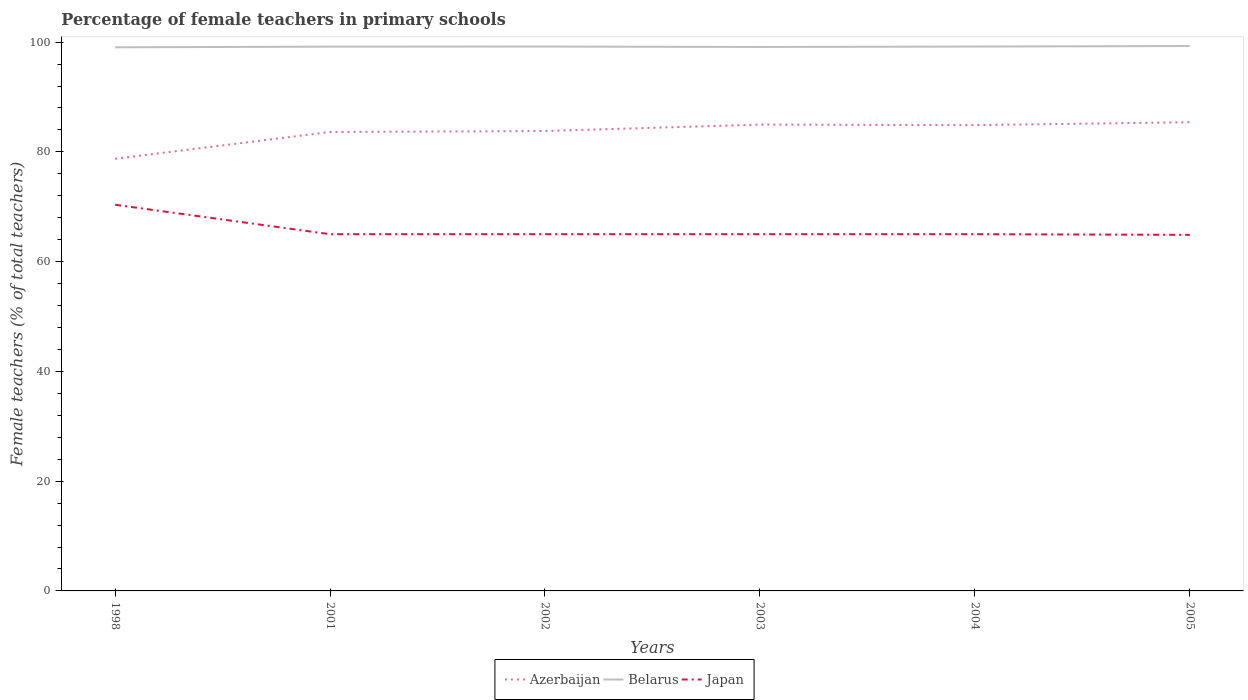How many different coloured lines are there?
Ensure brevity in your answer.  3. Is the number of lines equal to the number of legend labels?
Offer a terse response. Yes. Across all years, what is the maximum percentage of female teachers in Belarus?
Provide a succinct answer. 99.06. In which year was the percentage of female teachers in Azerbaijan maximum?
Your answer should be very brief. 1998. What is the total percentage of female teachers in Azerbaijan in the graph?
Your answer should be compact. -4.88. What is the difference between the highest and the second highest percentage of female teachers in Belarus?
Your response must be concise. 0.23. Is the percentage of female teachers in Azerbaijan strictly greater than the percentage of female teachers in Belarus over the years?
Your response must be concise. Yes. How many lines are there?
Your response must be concise. 3. What is the difference between two consecutive major ticks on the Y-axis?
Offer a very short reply. 20. Are the values on the major ticks of Y-axis written in scientific E-notation?
Provide a short and direct response. No. How many legend labels are there?
Make the answer very short. 3. What is the title of the graph?
Provide a short and direct response. Percentage of female teachers in primary schools. What is the label or title of the Y-axis?
Provide a succinct answer. Female teachers (% of total teachers). What is the Female teachers (% of total teachers) of Azerbaijan in 1998?
Ensure brevity in your answer.  78.75. What is the Female teachers (% of total teachers) of Belarus in 1998?
Provide a short and direct response. 99.06. What is the Female teachers (% of total teachers) in Japan in 1998?
Give a very brief answer. 70.37. What is the Female teachers (% of total teachers) of Azerbaijan in 2001?
Provide a short and direct response. 83.63. What is the Female teachers (% of total teachers) of Belarus in 2001?
Provide a succinct answer. 99.18. What is the Female teachers (% of total teachers) of Japan in 2001?
Give a very brief answer. 65. What is the Female teachers (% of total teachers) of Azerbaijan in 2002?
Keep it short and to the point. 83.81. What is the Female teachers (% of total teachers) in Belarus in 2002?
Your answer should be very brief. 99.2. What is the Female teachers (% of total teachers) of Japan in 2002?
Provide a short and direct response. 65. What is the Female teachers (% of total teachers) of Azerbaijan in 2003?
Offer a very short reply. 84.97. What is the Female teachers (% of total teachers) of Belarus in 2003?
Offer a very short reply. 99.12. What is the Female teachers (% of total teachers) of Japan in 2003?
Your response must be concise. 65. What is the Female teachers (% of total teachers) of Azerbaijan in 2004?
Offer a terse response. 84.88. What is the Female teachers (% of total teachers) in Belarus in 2004?
Offer a terse response. 99.2. What is the Female teachers (% of total teachers) of Japan in 2004?
Provide a succinct answer. 65. What is the Female teachers (% of total teachers) of Azerbaijan in 2005?
Offer a terse response. 85.41. What is the Female teachers (% of total teachers) of Belarus in 2005?
Provide a short and direct response. 99.29. What is the Female teachers (% of total teachers) of Japan in 2005?
Your answer should be very brief. 64.88. Across all years, what is the maximum Female teachers (% of total teachers) in Azerbaijan?
Provide a short and direct response. 85.41. Across all years, what is the maximum Female teachers (% of total teachers) of Belarus?
Provide a short and direct response. 99.29. Across all years, what is the maximum Female teachers (% of total teachers) of Japan?
Provide a short and direct response. 70.37. Across all years, what is the minimum Female teachers (% of total teachers) in Azerbaijan?
Provide a short and direct response. 78.75. Across all years, what is the minimum Female teachers (% of total teachers) in Belarus?
Your answer should be compact. 99.06. Across all years, what is the minimum Female teachers (% of total teachers) in Japan?
Keep it short and to the point. 64.88. What is the total Female teachers (% of total teachers) of Azerbaijan in the graph?
Provide a short and direct response. 501.44. What is the total Female teachers (% of total teachers) of Belarus in the graph?
Offer a terse response. 595.05. What is the total Female teachers (% of total teachers) of Japan in the graph?
Your answer should be very brief. 395.27. What is the difference between the Female teachers (% of total teachers) in Azerbaijan in 1998 and that in 2001?
Provide a short and direct response. -4.88. What is the difference between the Female teachers (% of total teachers) of Belarus in 1998 and that in 2001?
Make the answer very short. -0.12. What is the difference between the Female teachers (% of total teachers) of Japan in 1998 and that in 2001?
Provide a short and direct response. 5.37. What is the difference between the Female teachers (% of total teachers) of Azerbaijan in 1998 and that in 2002?
Your answer should be very brief. -5.06. What is the difference between the Female teachers (% of total teachers) of Belarus in 1998 and that in 2002?
Provide a succinct answer. -0.14. What is the difference between the Female teachers (% of total teachers) of Japan in 1998 and that in 2002?
Offer a very short reply. 5.37. What is the difference between the Female teachers (% of total teachers) of Azerbaijan in 1998 and that in 2003?
Make the answer very short. -6.23. What is the difference between the Female teachers (% of total teachers) of Belarus in 1998 and that in 2003?
Keep it short and to the point. -0.06. What is the difference between the Female teachers (% of total teachers) in Japan in 1998 and that in 2003?
Make the answer very short. 5.37. What is the difference between the Female teachers (% of total teachers) of Azerbaijan in 1998 and that in 2004?
Keep it short and to the point. -6.13. What is the difference between the Female teachers (% of total teachers) of Belarus in 1998 and that in 2004?
Provide a succinct answer. -0.14. What is the difference between the Female teachers (% of total teachers) of Japan in 1998 and that in 2004?
Provide a succinct answer. 5.37. What is the difference between the Female teachers (% of total teachers) of Azerbaijan in 1998 and that in 2005?
Your response must be concise. -6.66. What is the difference between the Female teachers (% of total teachers) of Belarus in 1998 and that in 2005?
Make the answer very short. -0.23. What is the difference between the Female teachers (% of total teachers) in Japan in 1998 and that in 2005?
Make the answer very short. 5.48. What is the difference between the Female teachers (% of total teachers) in Azerbaijan in 2001 and that in 2002?
Give a very brief answer. -0.18. What is the difference between the Female teachers (% of total teachers) in Belarus in 2001 and that in 2002?
Provide a short and direct response. -0.02. What is the difference between the Female teachers (% of total teachers) of Japan in 2001 and that in 2002?
Offer a terse response. -0. What is the difference between the Female teachers (% of total teachers) in Azerbaijan in 2001 and that in 2003?
Provide a succinct answer. -1.34. What is the difference between the Female teachers (% of total teachers) in Belarus in 2001 and that in 2003?
Provide a succinct answer. 0.06. What is the difference between the Female teachers (% of total teachers) in Japan in 2001 and that in 2003?
Provide a succinct answer. -0. What is the difference between the Female teachers (% of total teachers) of Azerbaijan in 2001 and that in 2004?
Give a very brief answer. -1.25. What is the difference between the Female teachers (% of total teachers) in Belarus in 2001 and that in 2004?
Provide a succinct answer. -0.01. What is the difference between the Female teachers (% of total teachers) of Japan in 2001 and that in 2004?
Your answer should be very brief. -0. What is the difference between the Female teachers (% of total teachers) of Azerbaijan in 2001 and that in 2005?
Your response must be concise. -1.78. What is the difference between the Female teachers (% of total teachers) in Belarus in 2001 and that in 2005?
Offer a very short reply. -0.11. What is the difference between the Female teachers (% of total teachers) of Japan in 2001 and that in 2005?
Offer a terse response. 0.12. What is the difference between the Female teachers (% of total teachers) of Azerbaijan in 2002 and that in 2003?
Keep it short and to the point. -1.17. What is the difference between the Female teachers (% of total teachers) of Belarus in 2002 and that in 2003?
Keep it short and to the point. 0.08. What is the difference between the Female teachers (% of total teachers) in Japan in 2002 and that in 2003?
Give a very brief answer. -0. What is the difference between the Female teachers (% of total teachers) of Azerbaijan in 2002 and that in 2004?
Your response must be concise. -1.07. What is the difference between the Female teachers (% of total teachers) of Belarus in 2002 and that in 2004?
Offer a terse response. 0. What is the difference between the Female teachers (% of total teachers) of Japan in 2002 and that in 2004?
Provide a short and direct response. -0. What is the difference between the Female teachers (% of total teachers) of Azerbaijan in 2002 and that in 2005?
Offer a very short reply. -1.6. What is the difference between the Female teachers (% of total teachers) of Belarus in 2002 and that in 2005?
Your answer should be compact. -0.1. What is the difference between the Female teachers (% of total teachers) of Japan in 2002 and that in 2005?
Your answer should be very brief. 0.12. What is the difference between the Female teachers (% of total teachers) of Azerbaijan in 2003 and that in 2004?
Keep it short and to the point. 0.1. What is the difference between the Female teachers (% of total teachers) of Belarus in 2003 and that in 2004?
Keep it short and to the point. -0.08. What is the difference between the Female teachers (% of total teachers) in Japan in 2003 and that in 2004?
Your answer should be very brief. 0. What is the difference between the Female teachers (% of total teachers) of Azerbaijan in 2003 and that in 2005?
Offer a very short reply. -0.44. What is the difference between the Female teachers (% of total teachers) of Belarus in 2003 and that in 2005?
Your answer should be very brief. -0.17. What is the difference between the Female teachers (% of total teachers) of Japan in 2003 and that in 2005?
Your answer should be very brief. 0.12. What is the difference between the Female teachers (% of total teachers) of Azerbaijan in 2004 and that in 2005?
Provide a short and direct response. -0.53. What is the difference between the Female teachers (% of total teachers) of Belarus in 2004 and that in 2005?
Offer a terse response. -0.1. What is the difference between the Female teachers (% of total teachers) in Japan in 2004 and that in 2005?
Ensure brevity in your answer.  0.12. What is the difference between the Female teachers (% of total teachers) in Azerbaijan in 1998 and the Female teachers (% of total teachers) in Belarus in 2001?
Your response must be concise. -20.44. What is the difference between the Female teachers (% of total teachers) in Azerbaijan in 1998 and the Female teachers (% of total teachers) in Japan in 2001?
Provide a succinct answer. 13.74. What is the difference between the Female teachers (% of total teachers) of Belarus in 1998 and the Female teachers (% of total teachers) of Japan in 2001?
Your answer should be compact. 34.06. What is the difference between the Female teachers (% of total teachers) in Azerbaijan in 1998 and the Female teachers (% of total teachers) in Belarus in 2002?
Give a very brief answer. -20.45. What is the difference between the Female teachers (% of total teachers) in Azerbaijan in 1998 and the Female teachers (% of total teachers) in Japan in 2002?
Give a very brief answer. 13.74. What is the difference between the Female teachers (% of total teachers) in Belarus in 1998 and the Female teachers (% of total teachers) in Japan in 2002?
Provide a succinct answer. 34.06. What is the difference between the Female teachers (% of total teachers) of Azerbaijan in 1998 and the Female teachers (% of total teachers) of Belarus in 2003?
Your answer should be very brief. -20.37. What is the difference between the Female teachers (% of total teachers) of Azerbaijan in 1998 and the Female teachers (% of total teachers) of Japan in 2003?
Your answer should be compact. 13.74. What is the difference between the Female teachers (% of total teachers) of Belarus in 1998 and the Female teachers (% of total teachers) of Japan in 2003?
Your response must be concise. 34.06. What is the difference between the Female teachers (% of total teachers) of Azerbaijan in 1998 and the Female teachers (% of total teachers) of Belarus in 2004?
Your answer should be very brief. -20.45. What is the difference between the Female teachers (% of total teachers) in Azerbaijan in 1998 and the Female teachers (% of total teachers) in Japan in 2004?
Your answer should be very brief. 13.74. What is the difference between the Female teachers (% of total teachers) of Belarus in 1998 and the Female teachers (% of total teachers) of Japan in 2004?
Keep it short and to the point. 34.06. What is the difference between the Female teachers (% of total teachers) of Azerbaijan in 1998 and the Female teachers (% of total teachers) of Belarus in 2005?
Make the answer very short. -20.55. What is the difference between the Female teachers (% of total teachers) of Azerbaijan in 1998 and the Female teachers (% of total teachers) of Japan in 2005?
Keep it short and to the point. 13.86. What is the difference between the Female teachers (% of total teachers) of Belarus in 1998 and the Female teachers (% of total teachers) of Japan in 2005?
Your response must be concise. 34.17. What is the difference between the Female teachers (% of total teachers) of Azerbaijan in 2001 and the Female teachers (% of total teachers) of Belarus in 2002?
Keep it short and to the point. -15.57. What is the difference between the Female teachers (% of total teachers) in Azerbaijan in 2001 and the Female teachers (% of total teachers) in Japan in 2002?
Keep it short and to the point. 18.63. What is the difference between the Female teachers (% of total teachers) of Belarus in 2001 and the Female teachers (% of total teachers) of Japan in 2002?
Ensure brevity in your answer.  34.18. What is the difference between the Female teachers (% of total teachers) in Azerbaijan in 2001 and the Female teachers (% of total teachers) in Belarus in 2003?
Your answer should be very brief. -15.49. What is the difference between the Female teachers (% of total teachers) in Azerbaijan in 2001 and the Female teachers (% of total teachers) in Japan in 2003?
Provide a short and direct response. 18.63. What is the difference between the Female teachers (% of total teachers) of Belarus in 2001 and the Female teachers (% of total teachers) of Japan in 2003?
Keep it short and to the point. 34.18. What is the difference between the Female teachers (% of total teachers) in Azerbaijan in 2001 and the Female teachers (% of total teachers) in Belarus in 2004?
Your answer should be very brief. -15.57. What is the difference between the Female teachers (% of total teachers) of Azerbaijan in 2001 and the Female teachers (% of total teachers) of Japan in 2004?
Ensure brevity in your answer.  18.63. What is the difference between the Female teachers (% of total teachers) of Belarus in 2001 and the Female teachers (% of total teachers) of Japan in 2004?
Your response must be concise. 34.18. What is the difference between the Female teachers (% of total teachers) of Azerbaijan in 2001 and the Female teachers (% of total teachers) of Belarus in 2005?
Ensure brevity in your answer.  -15.67. What is the difference between the Female teachers (% of total teachers) in Azerbaijan in 2001 and the Female teachers (% of total teachers) in Japan in 2005?
Keep it short and to the point. 18.74. What is the difference between the Female teachers (% of total teachers) in Belarus in 2001 and the Female teachers (% of total teachers) in Japan in 2005?
Make the answer very short. 34.3. What is the difference between the Female teachers (% of total teachers) in Azerbaijan in 2002 and the Female teachers (% of total teachers) in Belarus in 2003?
Ensure brevity in your answer.  -15.31. What is the difference between the Female teachers (% of total teachers) of Azerbaijan in 2002 and the Female teachers (% of total teachers) of Japan in 2003?
Keep it short and to the point. 18.8. What is the difference between the Female teachers (% of total teachers) in Belarus in 2002 and the Female teachers (% of total teachers) in Japan in 2003?
Your answer should be compact. 34.2. What is the difference between the Female teachers (% of total teachers) of Azerbaijan in 2002 and the Female teachers (% of total teachers) of Belarus in 2004?
Offer a terse response. -15.39. What is the difference between the Female teachers (% of total teachers) of Azerbaijan in 2002 and the Female teachers (% of total teachers) of Japan in 2004?
Offer a terse response. 18.8. What is the difference between the Female teachers (% of total teachers) of Belarus in 2002 and the Female teachers (% of total teachers) of Japan in 2004?
Your response must be concise. 34.2. What is the difference between the Female teachers (% of total teachers) of Azerbaijan in 2002 and the Female teachers (% of total teachers) of Belarus in 2005?
Make the answer very short. -15.49. What is the difference between the Female teachers (% of total teachers) in Azerbaijan in 2002 and the Female teachers (% of total teachers) in Japan in 2005?
Provide a short and direct response. 18.92. What is the difference between the Female teachers (% of total teachers) of Belarus in 2002 and the Female teachers (% of total teachers) of Japan in 2005?
Provide a succinct answer. 34.31. What is the difference between the Female teachers (% of total teachers) in Azerbaijan in 2003 and the Female teachers (% of total teachers) in Belarus in 2004?
Your response must be concise. -14.22. What is the difference between the Female teachers (% of total teachers) of Azerbaijan in 2003 and the Female teachers (% of total teachers) of Japan in 2004?
Your response must be concise. 19.97. What is the difference between the Female teachers (% of total teachers) in Belarus in 2003 and the Female teachers (% of total teachers) in Japan in 2004?
Make the answer very short. 34.12. What is the difference between the Female teachers (% of total teachers) in Azerbaijan in 2003 and the Female teachers (% of total teachers) in Belarus in 2005?
Offer a very short reply. -14.32. What is the difference between the Female teachers (% of total teachers) of Azerbaijan in 2003 and the Female teachers (% of total teachers) of Japan in 2005?
Provide a short and direct response. 20.09. What is the difference between the Female teachers (% of total teachers) of Belarus in 2003 and the Female teachers (% of total teachers) of Japan in 2005?
Your answer should be very brief. 34.24. What is the difference between the Female teachers (% of total teachers) of Azerbaijan in 2004 and the Female teachers (% of total teachers) of Belarus in 2005?
Your response must be concise. -14.42. What is the difference between the Female teachers (% of total teachers) in Azerbaijan in 2004 and the Female teachers (% of total teachers) in Japan in 2005?
Offer a terse response. 19.99. What is the difference between the Female teachers (% of total teachers) in Belarus in 2004 and the Female teachers (% of total teachers) in Japan in 2005?
Provide a short and direct response. 34.31. What is the average Female teachers (% of total teachers) in Azerbaijan per year?
Give a very brief answer. 83.57. What is the average Female teachers (% of total teachers) in Belarus per year?
Make the answer very short. 99.18. What is the average Female teachers (% of total teachers) in Japan per year?
Offer a very short reply. 65.88. In the year 1998, what is the difference between the Female teachers (% of total teachers) of Azerbaijan and Female teachers (% of total teachers) of Belarus?
Offer a terse response. -20.31. In the year 1998, what is the difference between the Female teachers (% of total teachers) of Azerbaijan and Female teachers (% of total teachers) of Japan?
Your response must be concise. 8.38. In the year 1998, what is the difference between the Female teachers (% of total teachers) of Belarus and Female teachers (% of total teachers) of Japan?
Your response must be concise. 28.69. In the year 2001, what is the difference between the Female teachers (% of total teachers) of Azerbaijan and Female teachers (% of total teachers) of Belarus?
Ensure brevity in your answer.  -15.55. In the year 2001, what is the difference between the Female teachers (% of total teachers) in Azerbaijan and Female teachers (% of total teachers) in Japan?
Provide a succinct answer. 18.63. In the year 2001, what is the difference between the Female teachers (% of total teachers) in Belarus and Female teachers (% of total teachers) in Japan?
Your answer should be very brief. 34.18. In the year 2002, what is the difference between the Female teachers (% of total teachers) in Azerbaijan and Female teachers (% of total teachers) in Belarus?
Your answer should be compact. -15.39. In the year 2002, what is the difference between the Female teachers (% of total teachers) of Azerbaijan and Female teachers (% of total teachers) of Japan?
Your answer should be compact. 18.8. In the year 2002, what is the difference between the Female teachers (% of total teachers) of Belarus and Female teachers (% of total teachers) of Japan?
Offer a very short reply. 34.2. In the year 2003, what is the difference between the Female teachers (% of total teachers) in Azerbaijan and Female teachers (% of total teachers) in Belarus?
Offer a very short reply. -14.15. In the year 2003, what is the difference between the Female teachers (% of total teachers) of Azerbaijan and Female teachers (% of total teachers) of Japan?
Keep it short and to the point. 19.97. In the year 2003, what is the difference between the Female teachers (% of total teachers) of Belarus and Female teachers (% of total teachers) of Japan?
Provide a short and direct response. 34.12. In the year 2004, what is the difference between the Female teachers (% of total teachers) in Azerbaijan and Female teachers (% of total teachers) in Belarus?
Ensure brevity in your answer.  -14.32. In the year 2004, what is the difference between the Female teachers (% of total teachers) of Azerbaijan and Female teachers (% of total teachers) of Japan?
Your answer should be very brief. 19.87. In the year 2004, what is the difference between the Female teachers (% of total teachers) of Belarus and Female teachers (% of total teachers) of Japan?
Your response must be concise. 34.19. In the year 2005, what is the difference between the Female teachers (% of total teachers) in Azerbaijan and Female teachers (% of total teachers) in Belarus?
Your response must be concise. -13.89. In the year 2005, what is the difference between the Female teachers (% of total teachers) in Azerbaijan and Female teachers (% of total teachers) in Japan?
Your response must be concise. 20.52. In the year 2005, what is the difference between the Female teachers (% of total teachers) of Belarus and Female teachers (% of total teachers) of Japan?
Your response must be concise. 34.41. What is the ratio of the Female teachers (% of total teachers) in Azerbaijan in 1998 to that in 2001?
Keep it short and to the point. 0.94. What is the ratio of the Female teachers (% of total teachers) in Japan in 1998 to that in 2001?
Ensure brevity in your answer.  1.08. What is the ratio of the Female teachers (% of total teachers) of Azerbaijan in 1998 to that in 2002?
Offer a very short reply. 0.94. What is the ratio of the Female teachers (% of total teachers) of Belarus in 1998 to that in 2002?
Ensure brevity in your answer.  1. What is the ratio of the Female teachers (% of total teachers) in Japan in 1998 to that in 2002?
Offer a terse response. 1.08. What is the ratio of the Female teachers (% of total teachers) of Azerbaijan in 1998 to that in 2003?
Make the answer very short. 0.93. What is the ratio of the Female teachers (% of total teachers) in Belarus in 1998 to that in 2003?
Your answer should be compact. 1. What is the ratio of the Female teachers (% of total teachers) in Japan in 1998 to that in 2003?
Ensure brevity in your answer.  1.08. What is the ratio of the Female teachers (% of total teachers) in Azerbaijan in 1998 to that in 2004?
Keep it short and to the point. 0.93. What is the ratio of the Female teachers (% of total teachers) in Japan in 1998 to that in 2004?
Your answer should be very brief. 1.08. What is the ratio of the Female teachers (% of total teachers) in Azerbaijan in 1998 to that in 2005?
Your answer should be compact. 0.92. What is the ratio of the Female teachers (% of total teachers) in Belarus in 1998 to that in 2005?
Your response must be concise. 1. What is the ratio of the Female teachers (% of total teachers) in Japan in 1998 to that in 2005?
Provide a succinct answer. 1.08. What is the ratio of the Female teachers (% of total teachers) in Azerbaijan in 2001 to that in 2003?
Give a very brief answer. 0.98. What is the ratio of the Female teachers (% of total teachers) in Japan in 2001 to that in 2003?
Keep it short and to the point. 1. What is the ratio of the Female teachers (% of total teachers) of Azerbaijan in 2001 to that in 2004?
Keep it short and to the point. 0.99. What is the ratio of the Female teachers (% of total teachers) in Belarus in 2001 to that in 2004?
Ensure brevity in your answer.  1. What is the ratio of the Female teachers (% of total teachers) in Azerbaijan in 2001 to that in 2005?
Provide a short and direct response. 0.98. What is the ratio of the Female teachers (% of total teachers) in Belarus in 2001 to that in 2005?
Make the answer very short. 1. What is the ratio of the Female teachers (% of total teachers) of Japan in 2001 to that in 2005?
Your response must be concise. 1. What is the ratio of the Female teachers (% of total teachers) of Azerbaijan in 2002 to that in 2003?
Offer a terse response. 0.99. What is the ratio of the Female teachers (% of total teachers) of Azerbaijan in 2002 to that in 2004?
Provide a short and direct response. 0.99. What is the ratio of the Female teachers (% of total teachers) in Japan in 2002 to that in 2004?
Provide a short and direct response. 1. What is the ratio of the Female teachers (% of total teachers) in Azerbaijan in 2002 to that in 2005?
Ensure brevity in your answer.  0.98. What is the ratio of the Female teachers (% of total teachers) of Belarus in 2002 to that in 2005?
Make the answer very short. 1. What is the ratio of the Female teachers (% of total teachers) of Belarus in 2003 to that in 2004?
Keep it short and to the point. 1. What is the ratio of the Female teachers (% of total teachers) of Azerbaijan in 2003 to that in 2005?
Make the answer very short. 0.99. What is the ratio of the Female teachers (% of total teachers) of Belarus in 2003 to that in 2005?
Offer a terse response. 1. What is the difference between the highest and the second highest Female teachers (% of total teachers) of Azerbaijan?
Provide a short and direct response. 0.44. What is the difference between the highest and the second highest Female teachers (% of total teachers) in Belarus?
Make the answer very short. 0.1. What is the difference between the highest and the second highest Female teachers (% of total teachers) in Japan?
Your response must be concise. 5.37. What is the difference between the highest and the lowest Female teachers (% of total teachers) in Azerbaijan?
Provide a short and direct response. 6.66. What is the difference between the highest and the lowest Female teachers (% of total teachers) in Belarus?
Provide a short and direct response. 0.23. What is the difference between the highest and the lowest Female teachers (% of total teachers) in Japan?
Offer a terse response. 5.48. 